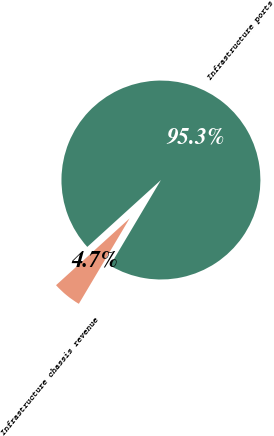<chart> <loc_0><loc_0><loc_500><loc_500><pie_chart><fcel>Infrastructure chassis revenue<fcel>Infrastructure ports<nl><fcel>4.73%<fcel>95.27%<nl></chart> 